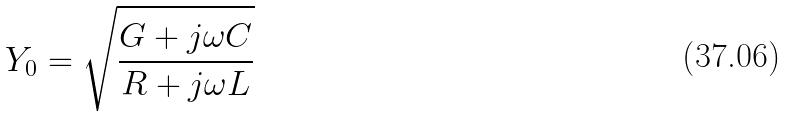Convert formula to latex. <formula><loc_0><loc_0><loc_500><loc_500>Y _ { 0 } = \sqrt { \frac { G + j \omega C } { R + j \omega L } }</formula> 